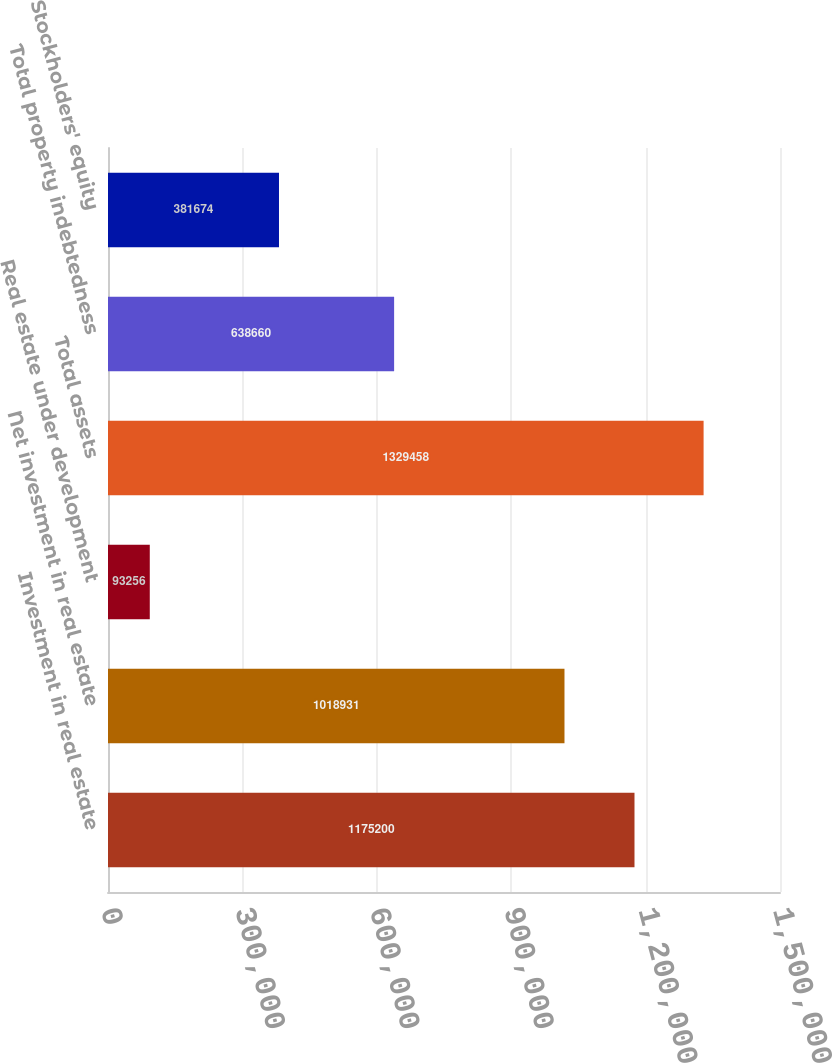Convert chart to OTSL. <chart><loc_0><loc_0><loc_500><loc_500><bar_chart><fcel>Investment in real estate<fcel>Net investment in real estate<fcel>Real estate under development<fcel>Total assets<fcel>Total property indebtedness<fcel>Stockholders' equity<nl><fcel>1.1752e+06<fcel>1.01893e+06<fcel>93256<fcel>1.32946e+06<fcel>638660<fcel>381674<nl></chart> 